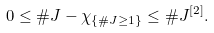Convert formula to latex. <formula><loc_0><loc_0><loc_500><loc_500>0 \leq \# J - \chi _ { \{ \# J \geq 1 \} } \leq \# J ^ { [ 2 ] } .</formula> 